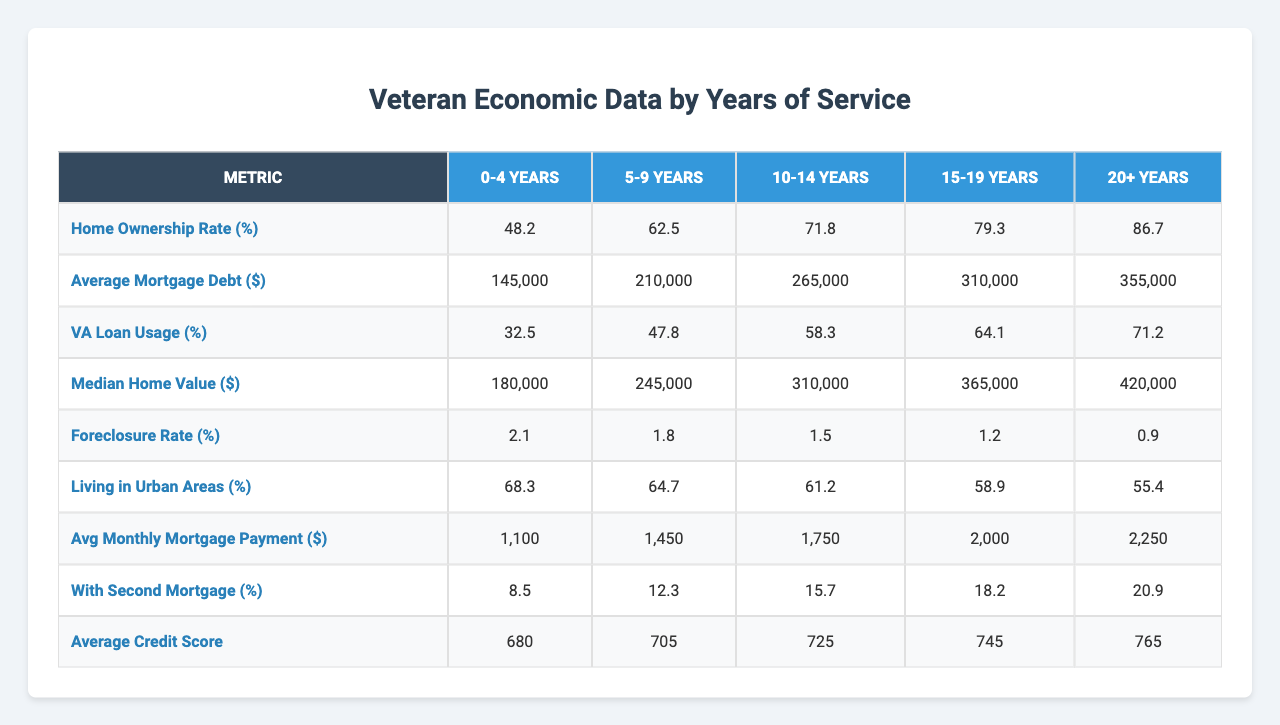What is the home ownership rate for veterans with 20 or more years of service? The home ownership rate for the group "20+" is given directly in the table as 86.7%.
Answer: 86.7% What is the average mortgage debt for veterans who have served between 10 to 14 years? Referring to the table, the average mortgage debt for the "10-14" years group is listed as $265,000.
Answer: $265,000 Is the VA loan usage percentage higher for veterans with 15 to 19 years of service compared to those with 0 to 4 years? The VA loan usage percentage for "15-19" years is 64.1%, while for "0-4" years it is 32.5%. Since 64.1% is greater than 32.5%, the answer is yes.
Answer: Yes What is the difference in average credit score between veterans with 5 to 9 years of service and those with 20 or more years of service? The average credit score for the "5-9" years group is 705 and for "20+" is 765. The difference is 765 - 705 = 60.
Answer: 60 What is the trend in home ownership rates as years of service increase? Observing the table, home ownership increases from 48.2% for "0-4" years to 86.7% for "20+" years. This indicates a positive trend as years of service increase.
Answer: Positive trend What is the average of the median home values for veterans with 5 to 9 years and 10 to 14 years of service combined? The median home values for "5-9" years and "10-14" years are $245,000 and $310,000, respectively. Summing these gives $555,000; averaging results in $555,000 / 2 = $277,500.
Answer: $277,500 What percentage of veterans with 0 to 4 years of service are living in urban areas? The percentage of veterans living in urban areas for the "0-4" years group is stated as 68.3%.
Answer: 68.3% Do more than 15% of veterans with 15 to 19 years of service have a second mortgage? The percentage of veterans with a second mortgage for "15-19" years is 18.2%, which is greater than 15%. Therefore, the answer is yes.
Answer: Yes If the foreclosure rate for veterans with 20 or more years of service is 0.9%, what is the average foreclosure rate across all service years? The foreclosure rates across all years are 2.1%, 1.8%, 1.5%, 1.2%, and 0.9%. Summing these gives 7.5% and dividing by 5 provides an average of 7.5% / 5 = 1.5%.
Answer: 1.5% What is the relationship between average mortgage payment and years of service in the data? Based on the table, average monthly mortgage payments increase from $1,100 for "0-4" years to $2,250 for "20+" years, indicating a positive correlation with years of service.
Answer: Positive correlation 